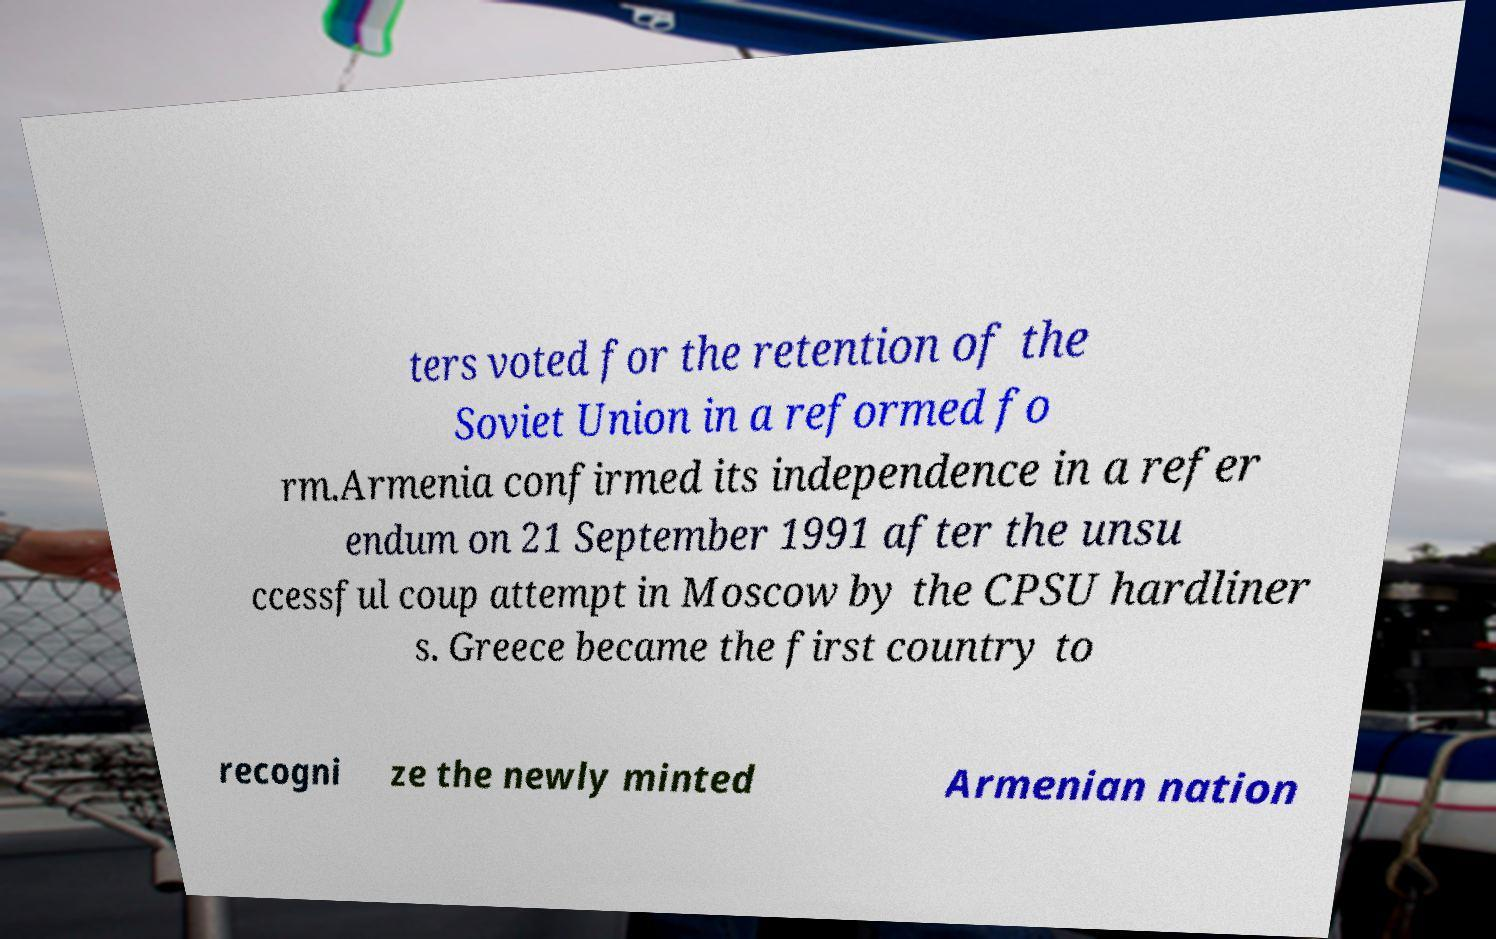Could you assist in decoding the text presented in this image and type it out clearly? ters voted for the retention of the Soviet Union in a reformed fo rm.Armenia confirmed its independence in a refer endum on 21 September 1991 after the unsu ccessful coup attempt in Moscow by the CPSU hardliner s. Greece became the first country to recogni ze the newly minted Armenian nation 